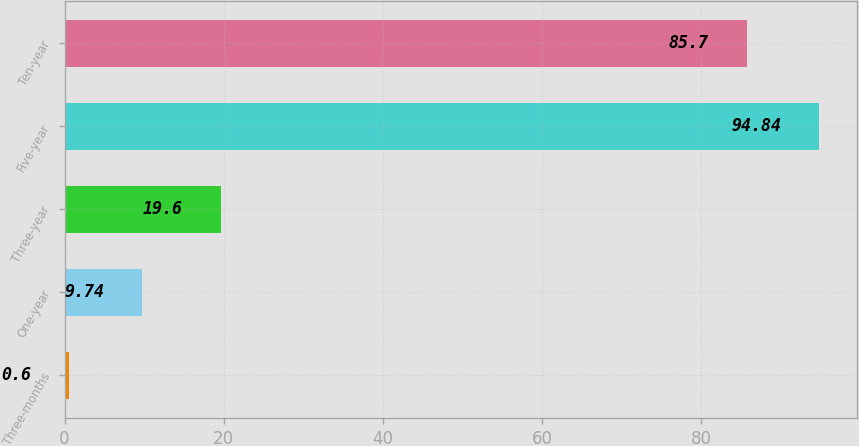Convert chart to OTSL. <chart><loc_0><loc_0><loc_500><loc_500><bar_chart><fcel>Three-months<fcel>One-year<fcel>Three-year<fcel>Five-year<fcel>Ten-year<nl><fcel>0.6<fcel>9.74<fcel>19.6<fcel>94.84<fcel>85.7<nl></chart> 